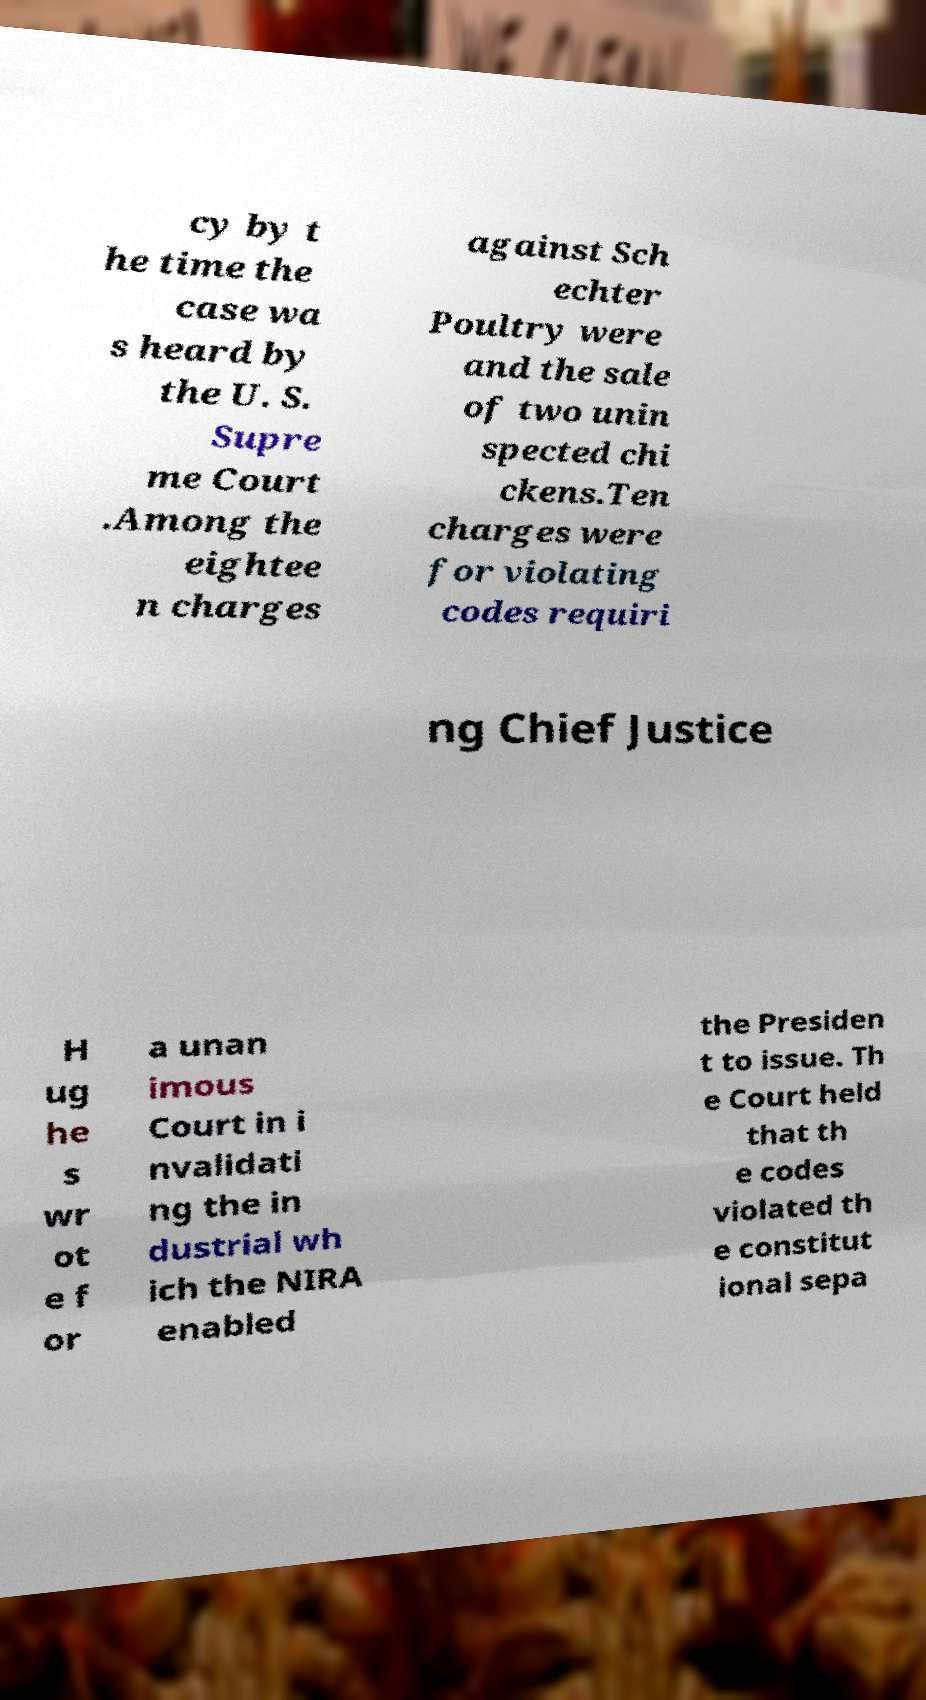For documentation purposes, I need the text within this image transcribed. Could you provide that? cy by t he time the case wa s heard by the U. S. Supre me Court .Among the eightee n charges against Sch echter Poultry were and the sale of two unin spected chi ckens.Ten charges were for violating codes requiri ng Chief Justice H ug he s wr ot e f or a unan imous Court in i nvalidati ng the in dustrial wh ich the NIRA enabled the Presiden t to issue. Th e Court held that th e codes violated th e constitut ional sepa 